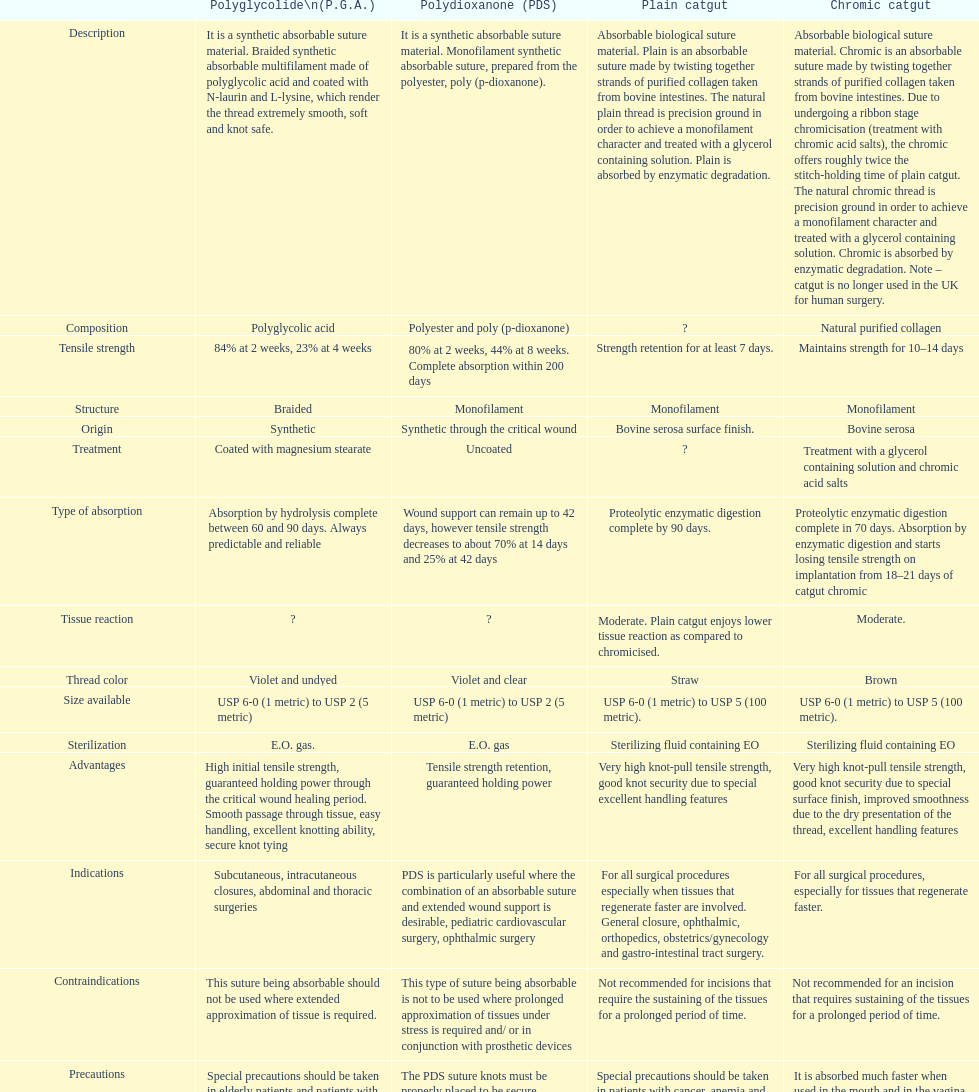What type of suture is not to be used in conjunction with prosthetic devices? Polydioxanone (PDS). 